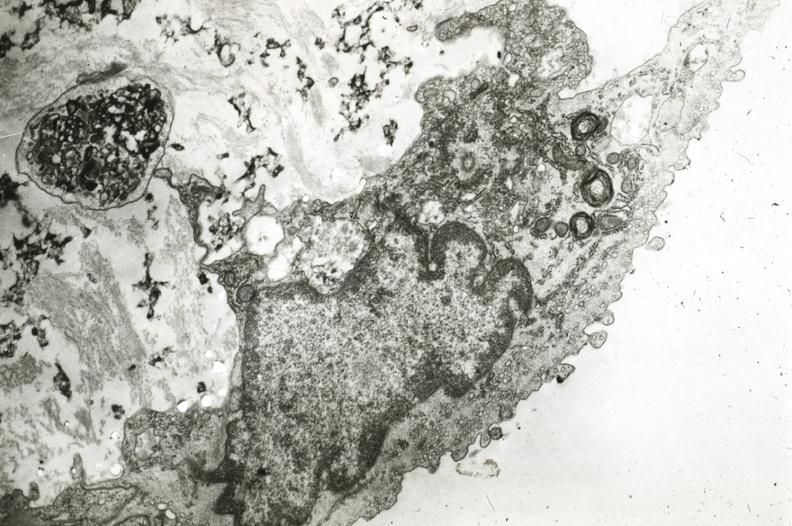what does this image show?
Answer the question using a single word or phrase. Endothelium with myelin bodies precipitated lipid in interstitial space 